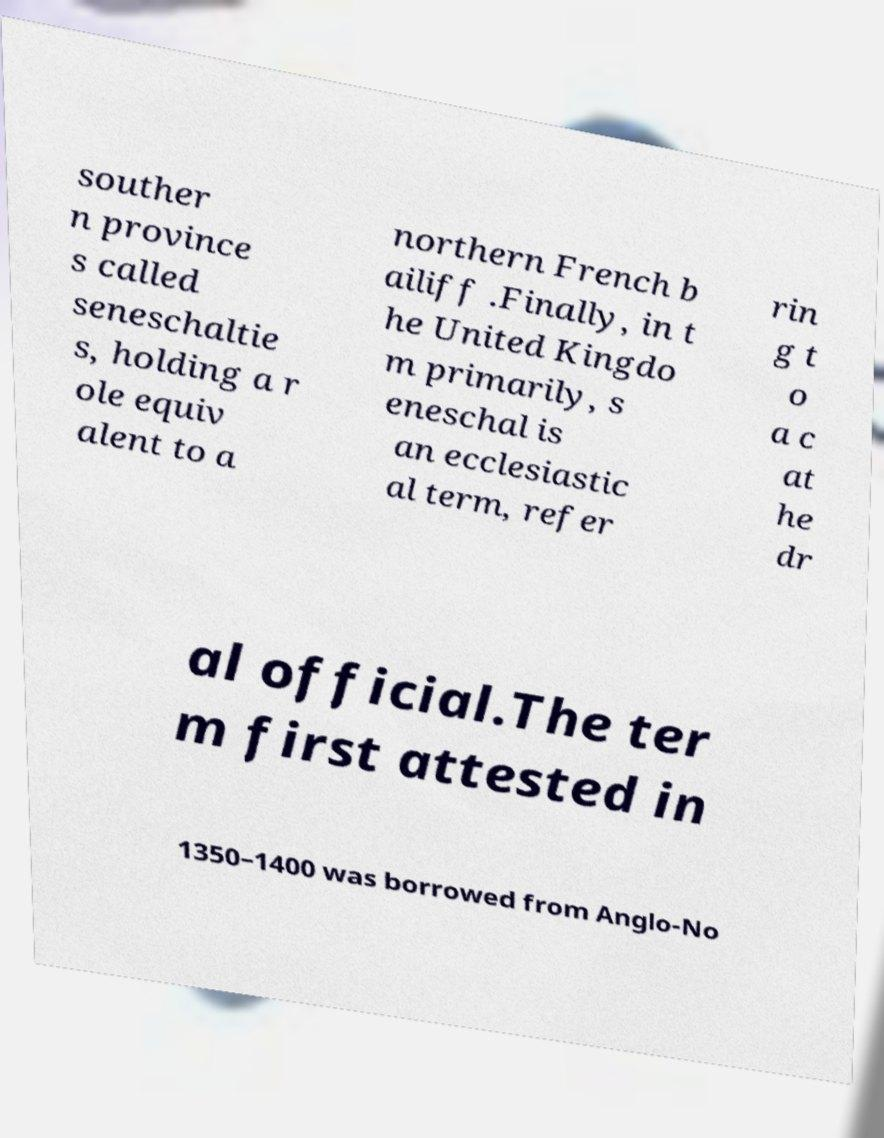Can you accurately transcribe the text from the provided image for me? souther n province s called seneschaltie s, holding a r ole equiv alent to a northern French b ailiff .Finally, in t he United Kingdo m primarily, s eneschal is an ecclesiastic al term, refer rin g t o a c at he dr al official.The ter m first attested in 1350–1400 was borrowed from Anglo-No 